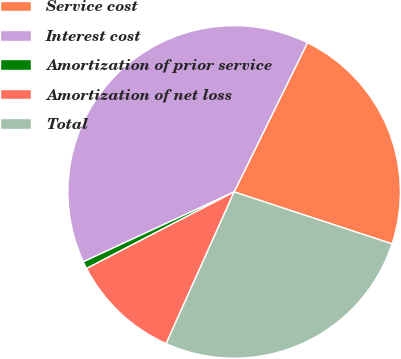Convert chart. <chart><loc_0><loc_0><loc_500><loc_500><pie_chart><fcel>Service cost<fcel>Interest cost<fcel>Amortization of prior service<fcel>Amortization of net loss<fcel>Total<nl><fcel>22.79%<fcel>39.17%<fcel>0.71%<fcel>10.68%<fcel>26.64%<nl></chart> 